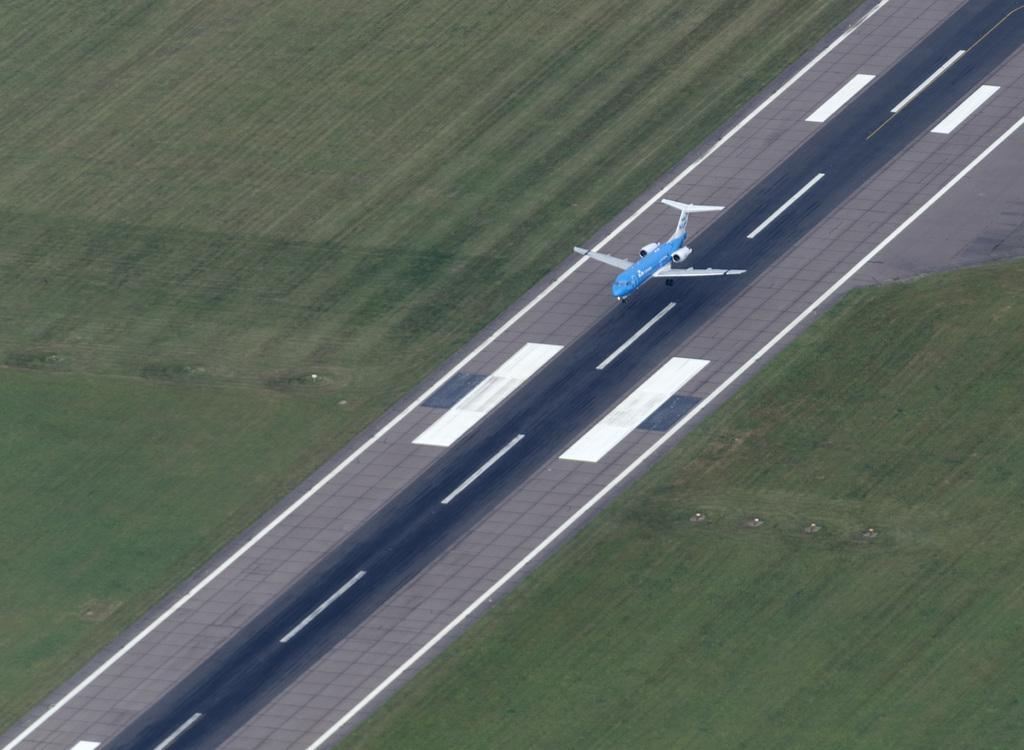Could you give a brief overview of what you see in this image? In this picture there is a blue color plane which is flying above the runway. On the both sides i can see the green grass. 